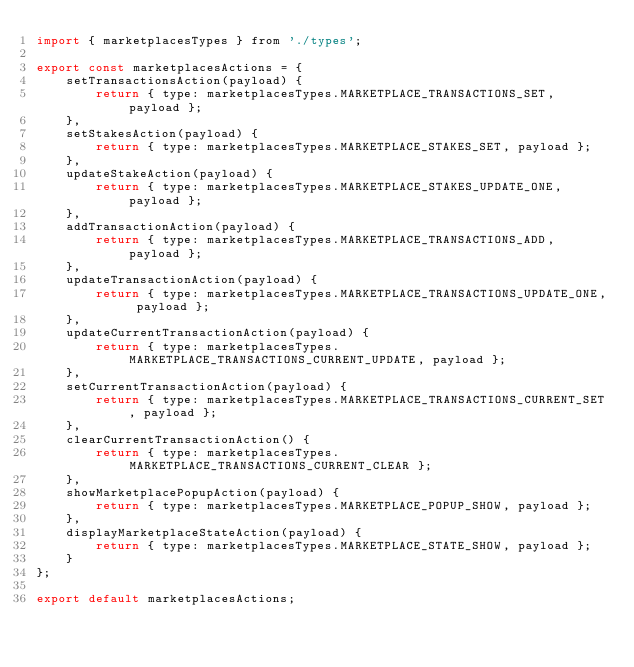<code> <loc_0><loc_0><loc_500><loc_500><_JavaScript_>import { marketplacesTypes } from './types';

export const marketplacesActions = {
	setTransactionsAction(payload) {
		return { type: marketplacesTypes.MARKETPLACE_TRANSACTIONS_SET, payload };
	},
	setStakesAction(payload) {
		return { type: marketplacesTypes.MARKETPLACE_STAKES_SET, payload };
	},
	updateStakeAction(payload) {
		return { type: marketplacesTypes.MARKETPLACE_STAKES_UPDATE_ONE, payload };
	},
	addTransactionAction(payload) {
		return { type: marketplacesTypes.MARKETPLACE_TRANSACTIONS_ADD, payload };
	},
	updateTransactionAction(payload) {
		return { type: marketplacesTypes.MARKETPLACE_TRANSACTIONS_UPDATE_ONE, payload };
	},
	updateCurrentTransactionAction(payload) {
		return { type: marketplacesTypes.MARKETPLACE_TRANSACTIONS_CURRENT_UPDATE, payload };
	},
	setCurrentTransactionAction(payload) {
		return { type: marketplacesTypes.MARKETPLACE_TRANSACTIONS_CURRENT_SET, payload };
	},
	clearCurrentTransactionAction() {
		return { type: marketplacesTypes.MARKETPLACE_TRANSACTIONS_CURRENT_CLEAR };
	},
	showMarketplacePopupAction(payload) {
		return { type: marketplacesTypes.MARKETPLACE_POPUP_SHOW, payload };
	},
	displayMarketplaceStateAction(payload) {
		return { type: marketplacesTypes.MARKETPLACE_STATE_SHOW, payload };
	}
};

export default marketplacesActions;
</code> 